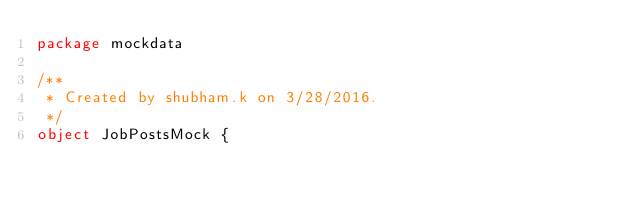<code> <loc_0><loc_0><loc_500><loc_500><_Scala_>package mockdata

/**
 * Created by shubham.k on 3/28/2016.
 */
object JobPostsMock {</code> 